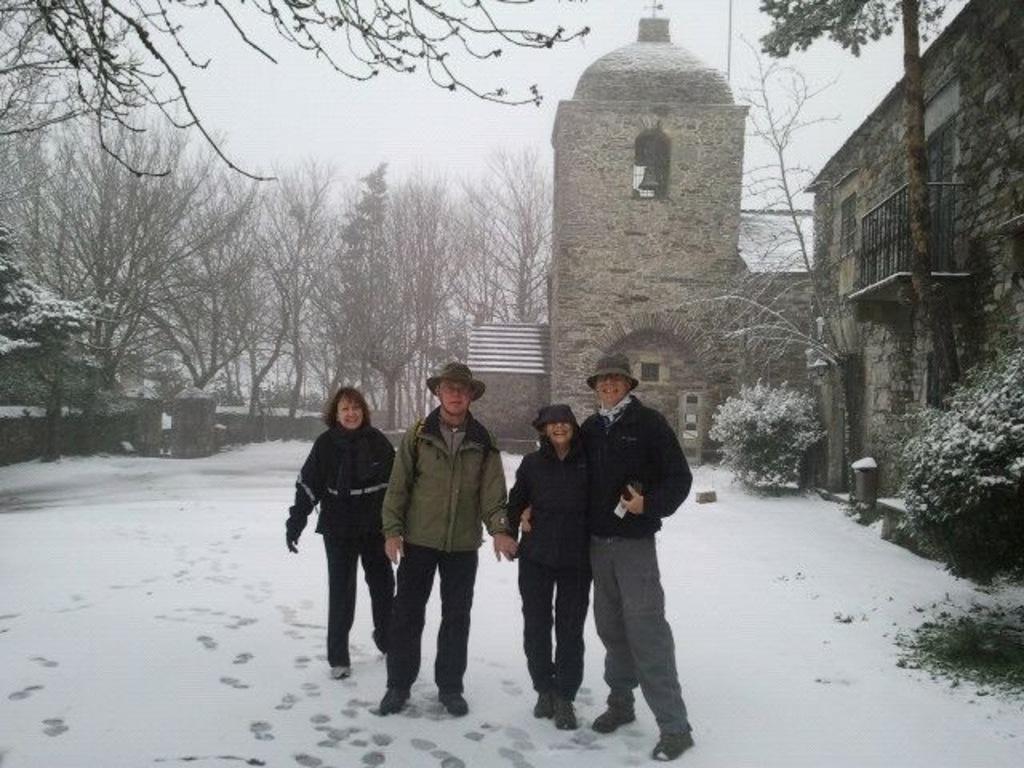Please provide a concise description of this image. In the foreground of the picture there are four people standing, they are wearing jackets and there is snow. On the right there are plants, trees and building. On the left there are trees. In the center of the picture towards background there are trees and building. Sky is foggy. 